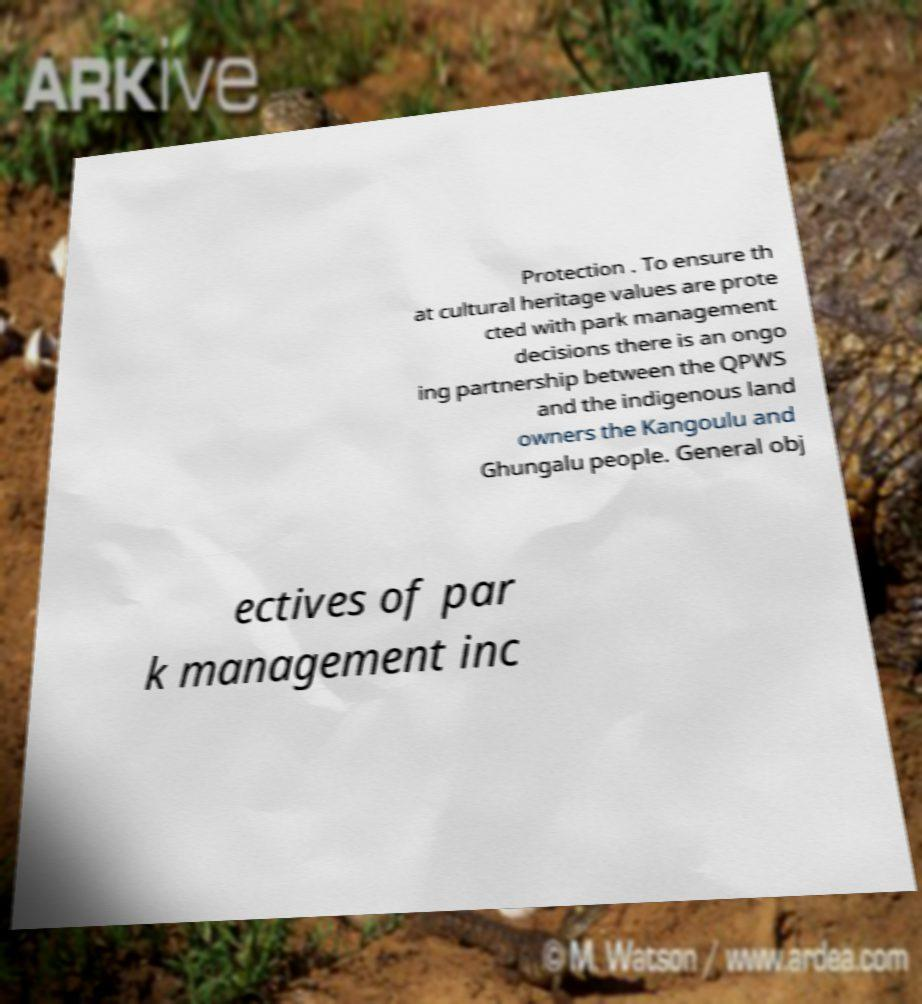Can you accurately transcribe the text from the provided image for me? Protection . To ensure th at cultural heritage values are prote cted with park management decisions there is an ongo ing partnership between the QPWS and the indigenous land owners the Kangoulu and Ghungalu people. General obj ectives of par k management inc 